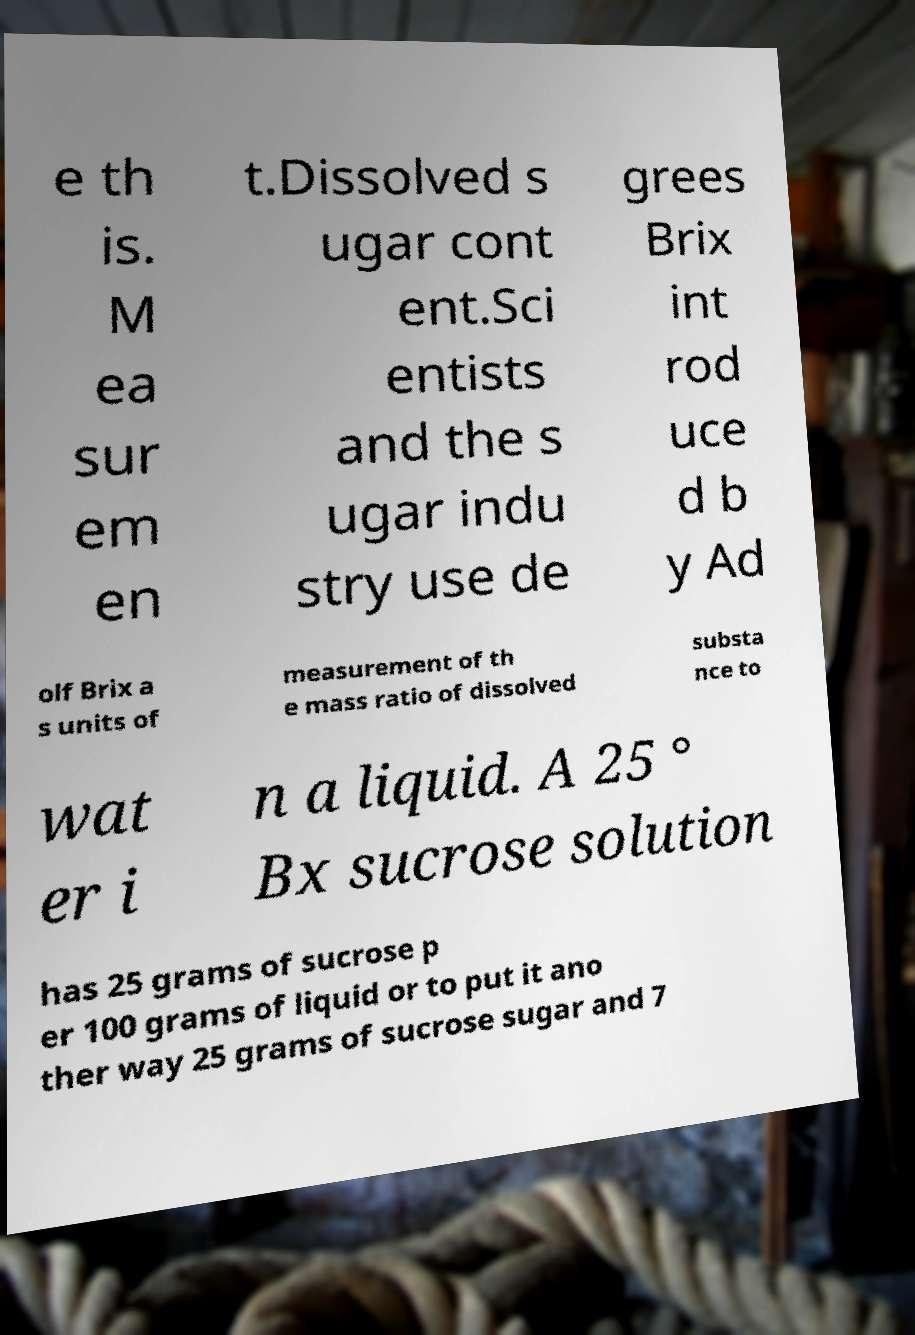For documentation purposes, I need the text within this image transcribed. Could you provide that? e th is. M ea sur em en t.Dissolved s ugar cont ent.Sci entists and the s ugar indu stry use de grees Brix int rod uce d b y Ad olf Brix a s units of measurement of th e mass ratio of dissolved substa nce to wat er i n a liquid. A 25 ° Bx sucrose solution has 25 grams of sucrose p er 100 grams of liquid or to put it ano ther way 25 grams of sucrose sugar and 7 